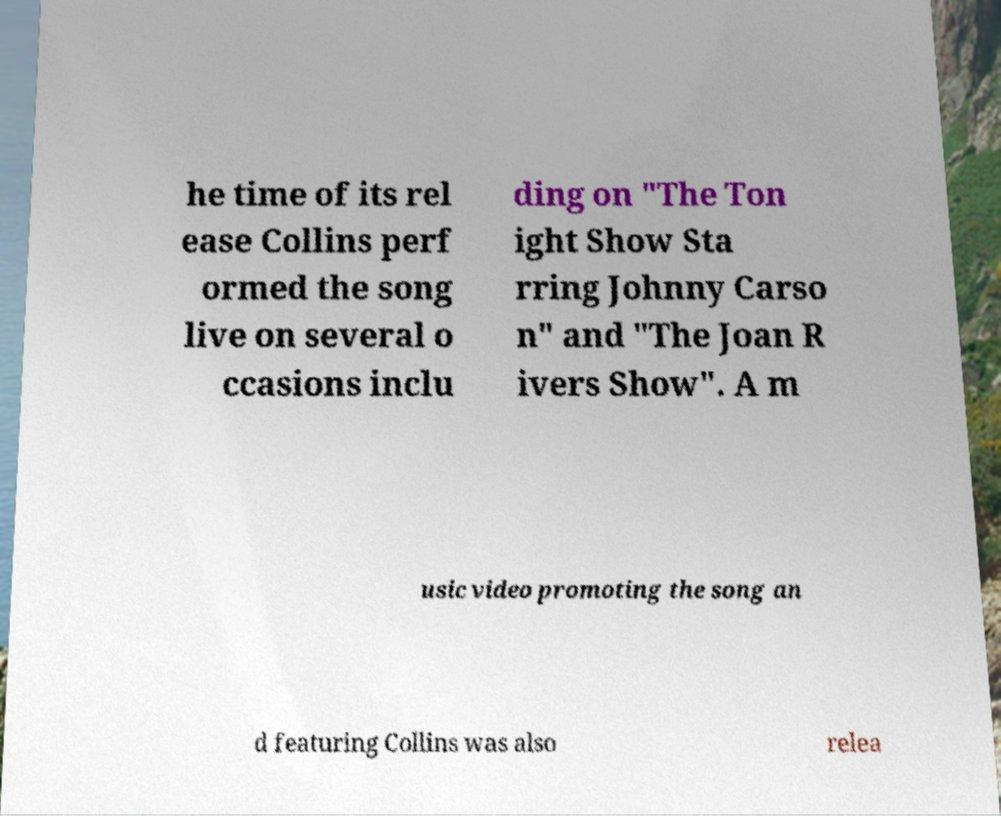What messages or text are displayed in this image? I need them in a readable, typed format. he time of its rel ease Collins perf ormed the song live on several o ccasions inclu ding on "The Ton ight Show Sta rring Johnny Carso n" and "The Joan R ivers Show". A m usic video promoting the song an d featuring Collins was also relea 